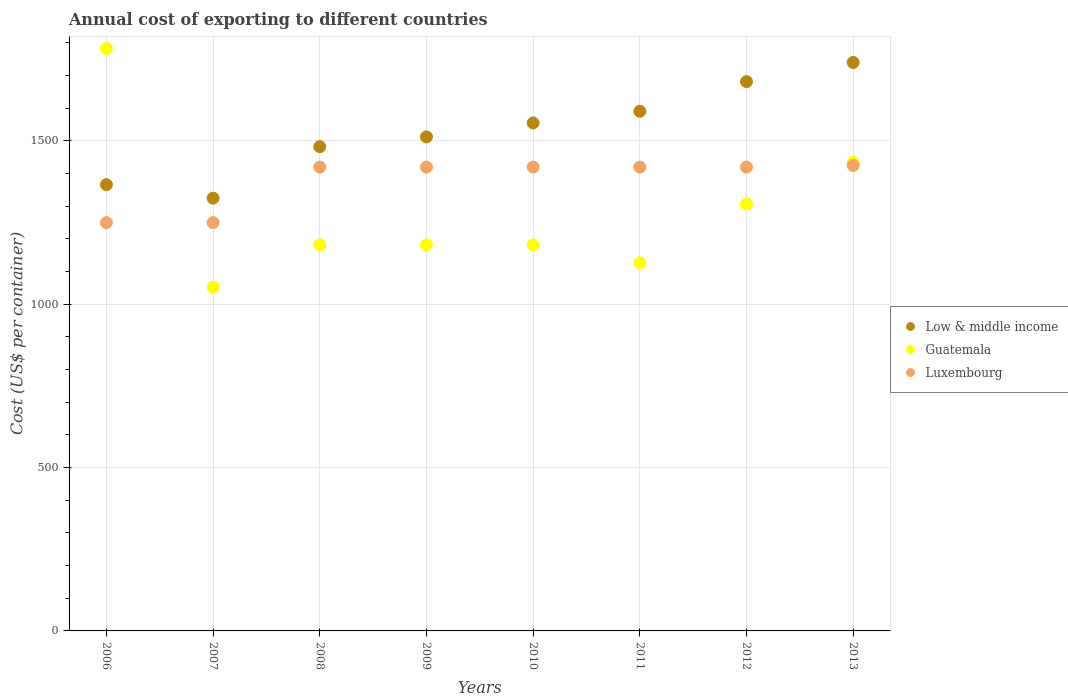How many different coloured dotlines are there?
Give a very brief answer. 3. Is the number of dotlines equal to the number of legend labels?
Offer a very short reply. Yes. What is the total annual cost of exporting in Luxembourg in 2007?
Provide a succinct answer. 1250. Across all years, what is the maximum total annual cost of exporting in Low & middle income?
Make the answer very short. 1740.31. Across all years, what is the minimum total annual cost of exporting in Guatemala?
Your answer should be very brief. 1052. In which year was the total annual cost of exporting in Luxembourg maximum?
Keep it short and to the point. 2013. In which year was the total annual cost of exporting in Luxembourg minimum?
Give a very brief answer. 2006. What is the total total annual cost of exporting in Guatemala in the graph?
Your response must be concise. 1.02e+04. What is the difference between the total annual cost of exporting in Low & middle income in 2011 and that in 2013?
Offer a very short reply. -149.51. What is the difference between the total annual cost of exporting in Guatemala in 2007 and the total annual cost of exporting in Luxembourg in 2010?
Give a very brief answer. -368. What is the average total annual cost of exporting in Luxembourg per year?
Ensure brevity in your answer.  1378.12. In the year 2012, what is the difference between the total annual cost of exporting in Low & middle income and total annual cost of exporting in Guatemala?
Your answer should be very brief. 374.57. In how many years, is the total annual cost of exporting in Guatemala greater than 500 US$?
Provide a succinct answer. 8. What is the ratio of the total annual cost of exporting in Luxembourg in 2008 to that in 2012?
Provide a short and direct response. 1. Is the difference between the total annual cost of exporting in Low & middle income in 2009 and 2010 greater than the difference between the total annual cost of exporting in Guatemala in 2009 and 2010?
Provide a succinct answer. No. What is the difference between the highest and the lowest total annual cost of exporting in Luxembourg?
Provide a succinct answer. 175. In how many years, is the total annual cost of exporting in Low & middle income greater than the average total annual cost of exporting in Low & middle income taken over all years?
Make the answer very short. 4. Is the total annual cost of exporting in Low & middle income strictly less than the total annual cost of exporting in Guatemala over the years?
Your answer should be compact. No. How many years are there in the graph?
Your answer should be very brief. 8. What is the difference between two consecutive major ticks on the Y-axis?
Make the answer very short. 500. Are the values on the major ticks of Y-axis written in scientific E-notation?
Your response must be concise. No. Does the graph contain grids?
Offer a very short reply. Yes. Where does the legend appear in the graph?
Offer a terse response. Center right. How are the legend labels stacked?
Your answer should be compact. Vertical. What is the title of the graph?
Make the answer very short. Annual cost of exporting to different countries. What is the label or title of the Y-axis?
Your answer should be very brief. Cost (US$ per container). What is the Cost (US$ per container) of Low & middle income in 2006?
Ensure brevity in your answer.  1366.18. What is the Cost (US$ per container) in Guatemala in 2006?
Your response must be concise. 1783. What is the Cost (US$ per container) of Luxembourg in 2006?
Offer a very short reply. 1250. What is the Cost (US$ per container) of Low & middle income in 2007?
Provide a succinct answer. 1324.86. What is the Cost (US$ per container) of Guatemala in 2007?
Offer a very short reply. 1052. What is the Cost (US$ per container) in Luxembourg in 2007?
Your answer should be very brief. 1250. What is the Cost (US$ per container) of Low & middle income in 2008?
Offer a very short reply. 1482.53. What is the Cost (US$ per container) of Guatemala in 2008?
Ensure brevity in your answer.  1182. What is the Cost (US$ per container) in Luxembourg in 2008?
Give a very brief answer. 1420. What is the Cost (US$ per container) in Low & middle income in 2009?
Offer a terse response. 1512.47. What is the Cost (US$ per container) of Guatemala in 2009?
Keep it short and to the point. 1182. What is the Cost (US$ per container) in Luxembourg in 2009?
Ensure brevity in your answer.  1420. What is the Cost (US$ per container) of Low & middle income in 2010?
Give a very brief answer. 1555.13. What is the Cost (US$ per container) of Guatemala in 2010?
Make the answer very short. 1182. What is the Cost (US$ per container) of Luxembourg in 2010?
Ensure brevity in your answer.  1420. What is the Cost (US$ per container) in Low & middle income in 2011?
Your response must be concise. 1590.8. What is the Cost (US$ per container) in Guatemala in 2011?
Offer a very short reply. 1127. What is the Cost (US$ per container) in Luxembourg in 2011?
Your answer should be compact. 1420. What is the Cost (US$ per container) of Low & middle income in 2012?
Offer a terse response. 1681.57. What is the Cost (US$ per container) in Guatemala in 2012?
Offer a terse response. 1307. What is the Cost (US$ per container) in Luxembourg in 2012?
Offer a terse response. 1420. What is the Cost (US$ per container) of Low & middle income in 2013?
Offer a terse response. 1740.31. What is the Cost (US$ per container) of Guatemala in 2013?
Ensure brevity in your answer.  1435. What is the Cost (US$ per container) of Luxembourg in 2013?
Give a very brief answer. 1425. Across all years, what is the maximum Cost (US$ per container) in Low & middle income?
Ensure brevity in your answer.  1740.31. Across all years, what is the maximum Cost (US$ per container) of Guatemala?
Your answer should be compact. 1783. Across all years, what is the maximum Cost (US$ per container) in Luxembourg?
Ensure brevity in your answer.  1425. Across all years, what is the minimum Cost (US$ per container) in Low & middle income?
Make the answer very short. 1324.86. Across all years, what is the minimum Cost (US$ per container) in Guatemala?
Offer a very short reply. 1052. Across all years, what is the minimum Cost (US$ per container) of Luxembourg?
Keep it short and to the point. 1250. What is the total Cost (US$ per container) in Low & middle income in the graph?
Your response must be concise. 1.23e+04. What is the total Cost (US$ per container) in Guatemala in the graph?
Keep it short and to the point. 1.02e+04. What is the total Cost (US$ per container) in Luxembourg in the graph?
Make the answer very short. 1.10e+04. What is the difference between the Cost (US$ per container) of Low & middle income in 2006 and that in 2007?
Ensure brevity in your answer.  41.32. What is the difference between the Cost (US$ per container) of Guatemala in 2006 and that in 2007?
Make the answer very short. 731. What is the difference between the Cost (US$ per container) of Luxembourg in 2006 and that in 2007?
Ensure brevity in your answer.  0. What is the difference between the Cost (US$ per container) in Low & middle income in 2006 and that in 2008?
Your response must be concise. -116.35. What is the difference between the Cost (US$ per container) of Guatemala in 2006 and that in 2008?
Offer a terse response. 601. What is the difference between the Cost (US$ per container) in Luxembourg in 2006 and that in 2008?
Keep it short and to the point. -170. What is the difference between the Cost (US$ per container) in Low & middle income in 2006 and that in 2009?
Ensure brevity in your answer.  -146.29. What is the difference between the Cost (US$ per container) in Guatemala in 2006 and that in 2009?
Your answer should be compact. 601. What is the difference between the Cost (US$ per container) of Luxembourg in 2006 and that in 2009?
Make the answer very short. -170. What is the difference between the Cost (US$ per container) in Low & middle income in 2006 and that in 2010?
Make the answer very short. -188.96. What is the difference between the Cost (US$ per container) of Guatemala in 2006 and that in 2010?
Your answer should be compact. 601. What is the difference between the Cost (US$ per container) in Luxembourg in 2006 and that in 2010?
Offer a terse response. -170. What is the difference between the Cost (US$ per container) in Low & middle income in 2006 and that in 2011?
Make the answer very short. -224.63. What is the difference between the Cost (US$ per container) of Guatemala in 2006 and that in 2011?
Your response must be concise. 656. What is the difference between the Cost (US$ per container) of Luxembourg in 2006 and that in 2011?
Offer a terse response. -170. What is the difference between the Cost (US$ per container) in Low & middle income in 2006 and that in 2012?
Offer a terse response. -315.39. What is the difference between the Cost (US$ per container) in Guatemala in 2006 and that in 2012?
Your response must be concise. 476. What is the difference between the Cost (US$ per container) in Luxembourg in 2006 and that in 2012?
Your answer should be compact. -170. What is the difference between the Cost (US$ per container) of Low & middle income in 2006 and that in 2013?
Make the answer very short. -374.13. What is the difference between the Cost (US$ per container) of Guatemala in 2006 and that in 2013?
Ensure brevity in your answer.  348. What is the difference between the Cost (US$ per container) in Luxembourg in 2006 and that in 2013?
Provide a succinct answer. -175. What is the difference between the Cost (US$ per container) in Low & middle income in 2007 and that in 2008?
Provide a short and direct response. -157.67. What is the difference between the Cost (US$ per container) in Guatemala in 2007 and that in 2008?
Give a very brief answer. -130. What is the difference between the Cost (US$ per container) in Luxembourg in 2007 and that in 2008?
Your response must be concise. -170. What is the difference between the Cost (US$ per container) in Low & middle income in 2007 and that in 2009?
Your answer should be very brief. -187.61. What is the difference between the Cost (US$ per container) in Guatemala in 2007 and that in 2009?
Keep it short and to the point. -130. What is the difference between the Cost (US$ per container) in Luxembourg in 2007 and that in 2009?
Offer a very short reply. -170. What is the difference between the Cost (US$ per container) of Low & middle income in 2007 and that in 2010?
Give a very brief answer. -230.28. What is the difference between the Cost (US$ per container) of Guatemala in 2007 and that in 2010?
Your answer should be very brief. -130. What is the difference between the Cost (US$ per container) of Luxembourg in 2007 and that in 2010?
Make the answer very short. -170. What is the difference between the Cost (US$ per container) of Low & middle income in 2007 and that in 2011?
Make the answer very short. -265.95. What is the difference between the Cost (US$ per container) of Guatemala in 2007 and that in 2011?
Provide a short and direct response. -75. What is the difference between the Cost (US$ per container) in Luxembourg in 2007 and that in 2011?
Make the answer very short. -170. What is the difference between the Cost (US$ per container) in Low & middle income in 2007 and that in 2012?
Give a very brief answer. -356.71. What is the difference between the Cost (US$ per container) of Guatemala in 2007 and that in 2012?
Offer a very short reply. -255. What is the difference between the Cost (US$ per container) of Luxembourg in 2007 and that in 2012?
Make the answer very short. -170. What is the difference between the Cost (US$ per container) of Low & middle income in 2007 and that in 2013?
Ensure brevity in your answer.  -415.45. What is the difference between the Cost (US$ per container) of Guatemala in 2007 and that in 2013?
Your answer should be very brief. -383. What is the difference between the Cost (US$ per container) in Luxembourg in 2007 and that in 2013?
Offer a very short reply. -175. What is the difference between the Cost (US$ per container) of Low & middle income in 2008 and that in 2009?
Your answer should be very brief. -29.94. What is the difference between the Cost (US$ per container) of Guatemala in 2008 and that in 2009?
Your response must be concise. 0. What is the difference between the Cost (US$ per container) of Low & middle income in 2008 and that in 2010?
Give a very brief answer. -72.61. What is the difference between the Cost (US$ per container) in Guatemala in 2008 and that in 2010?
Your response must be concise. 0. What is the difference between the Cost (US$ per container) of Luxembourg in 2008 and that in 2010?
Provide a succinct answer. 0. What is the difference between the Cost (US$ per container) in Low & middle income in 2008 and that in 2011?
Offer a terse response. -108.27. What is the difference between the Cost (US$ per container) in Low & middle income in 2008 and that in 2012?
Give a very brief answer. -199.04. What is the difference between the Cost (US$ per container) in Guatemala in 2008 and that in 2012?
Your answer should be very brief. -125. What is the difference between the Cost (US$ per container) in Low & middle income in 2008 and that in 2013?
Provide a short and direct response. -257.78. What is the difference between the Cost (US$ per container) of Guatemala in 2008 and that in 2013?
Provide a short and direct response. -253. What is the difference between the Cost (US$ per container) of Low & middle income in 2009 and that in 2010?
Your answer should be compact. -42.67. What is the difference between the Cost (US$ per container) in Guatemala in 2009 and that in 2010?
Your response must be concise. 0. What is the difference between the Cost (US$ per container) of Low & middle income in 2009 and that in 2011?
Your response must be concise. -78.33. What is the difference between the Cost (US$ per container) of Guatemala in 2009 and that in 2011?
Your response must be concise. 55. What is the difference between the Cost (US$ per container) in Luxembourg in 2009 and that in 2011?
Offer a terse response. 0. What is the difference between the Cost (US$ per container) of Low & middle income in 2009 and that in 2012?
Your answer should be very brief. -169.1. What is the difference between the Cost (US$ per container) of Guatemala in 2009 and that in 2012?
Ensure brevity in your answer.  -125. What is the difference between the Cost (US$ per container) in Luxembourg in 2009 and that in 2012?
Your response must be concise. 0. What is the difference between the Cost (US$ per container) in Low & middle income in 2009 and that in 2013?
Offer a very short reply. -227.84. What is the difference between the Cost (US$ per container) in Guatemala in 2009 and that in 2013?
Ensure brevity in your answer.  -253. What is the difference between the Cost (US$ per container) of Low & middle income in 2010 and that in 2011?
Give a very brief answer. -35.67. What is the difference between the Cost (US$ per container) in Guatemala in 2010 and that in 2011?
Make the answer very short. 55. What is the difference between the Cost (US$ per container) of Low & middle income in 2010 and that in 2012?
Provide a short and direct response. -126.43. What is the difference between the Cost (US$ per container) in Guatemala in 2010 and that in 2012?
Your answer should be compact. -125. What is the difference between the Cost (US$ per container) of Luxembourg in 2010 and that in 2012?
Your answer should be very brief. 0. What is the difference between the Cost (US$ per container) in Low & middle income in 2010 and that in 2013?
Provide a short and direct response. -185.17. What is the difference between the Cost (US$ per container) of Guatemala in 2010 and that in 2013?
Provide a short and direct response. -253. What is the difference between the Cost (US$ per container) in Luxembourg in 2010 and that in 2013?
Your answer should be compact. -5. What is the difference between the Cost (US$ per container) in Low & middle income in 2011 and that in 2012?
Provide a short and direct response. -90.76. What is the difference between the Cost (US$ per container) in Guatemala in 2011 and that in 2012?
Provide a succinct answer. -180. What is the difference between the Cost (US$ per container) in Luxembourg in 2011 and that in 2012?
Give a very brief answer. 0. What is the difference between the Cost (US$ per container) of Low & middle income in 2011 and that in 2013?
Your response must be concise. -149.51. What is the difference between the Cost (US$ per container) in Guatemala in 2011 and that in 2013?
Keep it short and to the point. -308. What is the difference between the Cost (US$ per container) of Luxembourg in 2011 and that in 2013?
Your answer should be very brief. -5. What is the difference between the Cost (US$ per container) of Low & middle income in 2012 and that in 2013?
Ensure brevity in your answer.  -58.74. What is the difference between the Cost (US$ per container) in Guatemala in 2012 and that in 2013?
Provide a succinct answer. -128. What is the difference between the Cost (US$ per container) in Luxembourg in 2012 and that in 2013?
Offer a terse response. -5. What is the difference between the Cost (US$ per container) in Low & middle income in 2006 and the Cost (US$ per container) in Guatemala in 2007?
Keep it short and to the point. 314.18. What is the difference between the Cost (US$ per container) of Low & middle income in 2006 and the Cost (US$ per container) of Luxembourg in 2007?
Ensure brevity in your answer.  116.18. What is the difference between the Cost (US$ per container) in Guatemala in 2006 and the Cost (US$ per container) in Luxembourg in 2007?
Provide a succinct answer. 533. What is the difference between the Cost (US$ per container) of Low & middle income in 2006 and the Cost (US$ per container) of Guatemala in 2008?
Ensure brevity in your answer.  184.18. What is the difference between the Cost (US$ per container) of Low & middle income in 2006 and the Cost (US$ per container) of Luxembourg in 2008?
Your answer should be compact. -53.82. What is the difference between the Cost (US$ per container) in Guatemala in 2006 and the Cost (US$ per container) in Luxembourg in 2008?
Give a very brief answer. 363. What is the difference between the Cost (US$ per container) of Low & middle income in 2006 and the Cost (US$ per container) of Guatemala in 2009?
Your answer should be compact. 184.18. What is the difference between the Cost (US$ per container) of Low & middle income in 2006 and the Cost (US$ per container) of Luxembourg in 2009?
Ensure brevity in your answer.  -53.82. What is the difference between the Cost (US$ per container) of Guatemala in 2006 and the Cost (US$ per container) of Luxembourg in 2009?
Your response must be concise. 363. What is the difference between the Cost (US$ per container) of Low & middle income in 2006 and the Cost (US$ per container) of Guatemala in 2010?
Keep it short and to the point. 184.18. What is the difference between the Cost (US$ per container) of Low & middle income in 2006 and the Cost (US$ per container) of Luxembourg in 2010?
Ensure brevity in your answer.  -53.82. What is the difference between the Cost (US$ per container) of Guatemala in 2006 and the Cost (US$ per container) of Luxembourg in 2010?
Offer a terse response. 363. What is the difference between the Cost (US$ per container) of Low & middle income in 2006 and the Cost (US$ per container) of Guatemala in 2011?
Your answer should be very brief. 239.18. What is the difference between the Cost (US$ per container) in Low & middle income in 2006 and the Cost (US$ per container) in Luxembourg in 2011?
Provide a short and direct response. -53.82. What is the difference between the Cost (US$ per container) of Guatemala in 2006 and the Cost (US$ per container) of Luxembourg in 2011?
Ensure brevity in your answer.  363. What is the difference between the Cost (US$ per container) of Low & middle income in 2006 and the Cost (US$ per container) of Guatemala in 2012?
Provide a short and direct response. 59.18. What is the difference between the Cost (US$ per container) of Low & middle income in 2006 and the Cost (US$ per container) of Luxembourg in 2012?
Give a very brief answer. -53.82. What is the difference between the Cost (US$ per container) in Guatemala in 2006 and the Cost (US$ per container) in Luxembourg in 2012?
Your answer should be compact. 363. What is the difference between the Cost (US$ per container) in Low & middle income in 2006 and the Cost (US$ per container) in Guatemala in 2013?
Provide a succinct answer. -68.82. What is the difference between the Cost (US$ per container) in Low & middle income in 2006 and the Cost (US$ per container) in Luxembourg in 2013?
Give a very brief answer. -58.82. What is the difference between the Cost (US$ per container) in Guatemala in 2006 and the Cost (US$ per container) in Luxembourg in 2013?
Offer a terse response. 358. What is the difference between the Cost (US$ per container) of Low & middle income in 2007 and the Cost (US$ per container) of Guatemala in 2008?
Provide a succinct answer. 142.86. What is the difference between the Cost (US$ per container) in Low & middle income in 2007 and the Cost (US$ per container) in Luxembourg in 2008?
Make the answer very short. -95.14. What is the difference between the Cost (US$ per container) in Guatemala in 2007 and the Cost (US$ per container) in Luxembourg in 2008?
Keep it short and to the point. -368. What is the difference between the Cost (US$ per container) of Low & middle income in 2007 and the Cost (US$ per container) of Guatemala in 2009?
Give a very brief answer. 142.86. What is the difference between the Cost (US$ per container) in Low & middle income in 2007 and the Cost (US$ per container) in Luxembourg in 2009?
Offer a very short reply. -95.14. What is the difference between the Cost (US$ per container) in Guatemala in 2007 and the Cost (US$ per container) in Luxembourg in 2009?
Ensure brevity in your answer.  -368. What is the difference between the Cost (US$ per container) in Low & middle income in 2007 and the Cost (US$ per container) in Guatemala in 2010?
Your answer should be compact. 142.86. What is the difference between the Cost (US$ per container) of Low & middle income in 2007 and the Cost (US$ per container) of Luxembourg in 2010?
Offer a very short reply. -95.14. What is the difference between the Cost (US$ per container) in Guatemala in 2007 and the Cost (US$ per container) in Luxembourg in 2010?
Provide a short and direct response. -368. What is the difference between the Cost (US$ per container) of Low & middle income in 2007 and the Cost (US$ per container) of Guatemala in 2011?
Your answer should be very brief. 197.86. What is the difference between the Cost (US$ per container) in Low & middle income in 2007 and the Cost (US$ per container) in Luxembourg in 2011?
Offer a very short reply. -95.14. What is the difference between the Cost (US$ per container) of Guatemala in 2007 and the Cost (US$ per container) of Luxembourg in 2011?
Keep it short and to the point. -368. What is the difference between the Cost (US$ per container) in Low & middle income in 2007 and the Cost (US$ per container) in Guatemala in 2012?
Offer a terse response. 17.86. What is the difference between the Cost (US$ per container) of Low & middle income in 2007 and the Cost (US$ per container) of Luxembourg in 2012?
Offer a terse response. -95.14. What is the difference between the Cost (US$ per container) in Guatemala in 2007 and the Cost (US$ per container) in Luxembourg in 2012?
Offer a terse response. -368. What is the difference between the Cost (US$ per container) in Low & middle income in 2007 and the Cost (US$ per container) in Guatemala in 2013?
Your answer should be compact. -110.14. What is the difference between the Cost (US$ per container) of Low & middle income in 2007 and the Cost (US$ per container) of Luxembourg in 2013?
Keep it short and to the point. -100.14. What is the difference between the Cost (US$ per container) of Guatemala in 2007 and the Cost (US$ per container) of Luxembourg in 2013?
Make the answer very short. -373. What is the difference between the Cost (US$ per container) in Low & middle income in 2008 and the Cost (US$ per container) in Guatemala in 2009?
Give a very brief answer. 300.53. What is the difference between the Cost (US$ per container) in Low & middle income in 2008 and the Cost (US$ per container) in Luxembourg in 2009?
Your answer should be compact. 62.53. What is the difference between the Cost (US$ per container) of Guatemala in 2008 and the Cost (US$ per container) of Luxembourg in 2009?
Offer a very short reply. -238. What is the difference between the Cost (US$ per container) of Low & middle income in 2008 and the Cost (US$ per container) of Guatemala in 2010?
Keep it short and to the point. 300.53. What is the difference between the Cost (US$ per container) of Low & middle income in 2008 and the Cost (US$ per container) of Luxembourg in 2010?
Ensure brevity in your answer.  62.53. What is the difference between the Cost (US$ per container) in Guatemala in 2008 and the Cost (US$ per container) in Luxembourg in 2010?
Ensure brevity in your answer.  -238. What is the difference between the Cost (US$ per container) of Low & middle income in 2008 and the Cost (US$ per container) of Guatemala in 2011?
Give a very brief answer. 355.53. What is the difference between the Cost (US$ per container) in Low & middle income in 2008 and the Cost (US$ per container) in Luxembourg in 2011?
Your answer should be very brief. 62.53. What is the difference between the Cost (US$ per container) in Guatemala in 2008 and the Cost (US$ per container) in Luxembourg in 2011?
Ensure brevity in your answer.  -238. What is the difference between the Cost (US$ per container) of Low & middle income in 2008 and the Cost (US$ per container) of Guatemala in 2012?
Give a very brief answer. 175.53. What is the difference between the Cost (US$ per container) in Low & middle income in 2008 and the Cost (US$ per container) in Luxembourg in 2012?
Your answer should be compact. 62.53. What is the difference between the Cost (US$ per container) of Guatemala in 2008 and the Cost (US$ per container) of Luxembourg in 2012?
Make the answer very short. -238. What is the difference between the Cost (US$ per container) of Low & middle income in 2008 and the Cost (US$ per container) of Guatemala in 2013?
Your answer should be very brief. 47.53. What is the difference between the Cost (US$ per container) of Low & middle income in 2008 and the Cost (US$ per container) of Luxembourg in 2013?
Offer a very short reply. 57.53. What is the difference between the Cost (US$ per container) of Guatemala in 2008 and the Cost (US$ per container) of Luxembourg in 2013?
Keep it short and to the point. -243. What is the difference between the Cost (US$ per container) in Low & middle income in 2009 and the Cost (US$ per container) in Guatemala in 2010?
Keep it short and to the point. 330.47. What is the difference between the Cost (US$ per container) of Low & middle income in 2009 and the Cost (US$ per container) of Luxembourg in 2010?
Your answer should be very brief. 92.47. What is the difference between the Cost (US$ per container) of Guatemala in 2009 and the Cost (US$ per container) of Luxembourg in 2010?
Give a very brief answer. -238. What is the difference between the Cost (US$ per container) of Low & middle income in 2009 and the Cost (US$ per container) of Guatemala in 2011?
Provide a short and direct response. 385.47. What is the difference between the Cost (US$ per container) of Low & middle income in 2009 and the Cost (US$ per container) of Luxembourg in 2011?
Ensure brevity in your answer.  92.47. What is the difference between the Cost (US$ per container) in Guatemala in 2009 and the Cost (US$ per container) in Luxembourg in 2011?
Your response must be concise. -238. What is the difference between the Cost (US$ per container) of Low & middle income in 2009 and the Cost (US$ per container) of Guatemala in 2012?
Provide a short and direct response. 205.47. What is the difference between the Cost (US$ per container) of Low & middle income in 2009 and the Cost (US$ per container) of Luxembourg in 2012?
Ensure brevity in your answer.  92.47. What is the difference between the Cost (US$ per container) in Guatemala in 2009 and the Cost (US$ per container) in Luxembourg in 2012?
Offer a terse response. -238. What is the difference between the Cost (US$ per container) in Low & middle income in 2009 and the Cost (US$ per container) in Guatemala in 2013?
Your response must be concise. 77.47. What is the difference between the Cost (US$ per container) of Low & middle income in 2009 and the Cost (US$ per container) of Luxembourg in 2013?
Your answer should be very brief. 87.47. What is the difference between the Cost (US$ per container) in Guatemala in 2009 and the Cost (US$ per container) in Luxembourg in 2013?
Offer a very short reply. -243. What is the difference between the Cost (US$ per container) of Low & middle income in 2010 and the Cost (US$ per container) of Guatemala in 2011?
Your answer should be very brief. 428.13. What is the difference between the Cost (US$ per container) of Low & middle income in 2010 and the Cost (US$ per container) of Luxembourg in 2011?
Provide a succinct answer. 135.13. What is the difference between the Cost (US$ per container) in Guatemala in 2010 and the Cost (US$ per container) in Luxembourg in 2011?
Make the answer very short. -238. What is the difference between the Cost (US$ per container) of Low & middle income in 2010 and the Cost (US$ per container) of Guatemala in 2012?
Ensure brevity in your answer.  248.13. What is the difference between the Cost (US$ per container) of Low & middle income in 2010 and the Cost (US$ per container) of Luxembourg in 2012?
Make the answer very short. 135.13. What is the difference between the Cost (US$ per container) of Guatemala in 2010 and the Cost (US$ per container) of Luxembourg in 2012?
Give a very brief answer. -238. What is the difference between the Cost (US$ per container) of Low & middle income in 2010 and the Cost (US$ per container) of Guatemala in 2013?
Your answer should be compact. 120.13. What is the difference between the Cost (US$ per container) in Low & middle income in 2010 and the Cost (US$ per container) in Luxembourg in 2013?
Ensure brevity in your answer.  130.13. What is the difference between the Cost (US$ per container) in Guatemala in 2010 and the Cost (US$ per container) in Luxembourg in 2013?
Make the answer very short. -243. What is the difference between the Cost (US$ per container) in Low & middle income in 2011 and the Cost (US$ per container) in Guatemala in 2012?
Keep it short and to the point. 283.8. What is the difference between the Cost (US$ per container) of Low & middle income in 2011 and the Cost (US$ per container) of Luxembourg in 2012?
Your response must be concise. 170.8. What is the difference between the Cost (US$ per container) of Guatemala in 2011 and the Cost (US$ per container) of Luxembourg in 2012?
Your response must be concise. -293. What is the difference between the Cost (US$ per container) in Low & middle income in 2011 and the Cost (US$ per container) in Guatemala in 2013?
Make the answer very short. 155.8. What is the difference between the Cost (US$ per container) of Low & middle income in 2011 and the Cost (US$ per container) of Luxembourg in 2013?
Provide a short and direct response. 165.8. What is the difference between the Cost (US$ per container) of Guatemala in 2011 and the Cost (US$ per container) of Luxembourg in 2013?
Provide a succinct answer. -298. What is the difference between the Cost (US$ per container) of Low & middle income in 2012 and the Cost (US$ per container) of Guatemala in 2013?
Your answer should be compact. 246.57. What is the difference between the Cost (US$ per container) in Low & middle income in 2012 and the Cost (US$ per container) in Luxembourg in 2013?
Provide a succinct answer. 256.57. What is the difference between the Cost (US$ per container) in Guatemala in 2012 and the Cost (US$ per container) in Luxembourg in 2013?
Ensure brevity in your answer.  -118. What is the average Cost (US$ per container) in Low & middle income per year?
Make the answer very short. 1531.73. What is the average Cost (US$ per container) of Guatemala per year?
Keep it short and to the point. 1281.25. What is the average Cost (US$ per container) in Luxembourg per year?
Keep it short and to the point. 1378.12. In the year 2006, what is the difference between the Cost (US$ per container) in Low & middle income and Cost (US$ per container) in Guatemala?
Your answer should be compact. -416.82. In the year 2006, what is the difference between the Cost (US$ per container) in Low & middle income and Cost (US$ per container) in Luxembourg?
Your answer should be very brief. 116.18. In the year 2006, what is the difference between the Cost (US$ per container) in Guatemala and Cost (US$ per container) in Luxembourg?
Offer a terse response. 533. In the year 2007, what is the difference between the Cost (US$ per container) in Low & middle income and Cost (US$ per container) in Guatemala?
Your answer should be compact. 272.86. In the year 2007, what is the difference between the Cost (US$ per container) of Low & middle income and Cost (US$ per container) of Luxembourg?
Provide a succinct answer. 74.86. In the year 2007, what is the difference between the Cost (US$ per container) in Guatemala and Cost (US$ per container) in Luxembourg?
Provide a succinct answer. -198. In the year 2008, what is the difference between the Cost (US$ per container) in Low & middle income and Cost (US$ per container) in Guatemala?
Keep it short and to the point. 300.53. In the year 2008, what is the difference between the Cost (US$ per container) of Low & middle income and Cost (US$ per container) of Luxembourg?
Offer a terse response. 62.53. In the year 2008, what is the difference between the Cost (US$ per container) in Guatemala and Cost (US$ per container) in Luxembourg?
Provide a succinct answer. -238. In the year 2009, what is the difference between the Cost (US$ per container) of Low & middle income and Cost (US$ per container) of Guatemala?
Offer a terse response. 330.47. In the year 2009, what is the difference between the Cost (US$ per container) in Low & middle income and Cost (US$ per container) in Luxembourg?
Offer a very short reply. 92.47. In the year 2009, what is the difference between the Cost (US$ per container) of Guatemala and Cost (US$ per container) of Luxembourg?
Give a very brief answer. -238. In the year 2010, what is the difference between the Cost (US$ per container) of Low & middle income and Cost (US$ per container) of Guatemala?
Your answer should be compact. 373.13. In the year 2010, what is the difference between the Cost (US$ per container) in Low & middle income and Cost (US$ per container) in Luxembourg?
Provide a succinct answer. 135.13. In the year 2010, what is the difference between the Cost (US$ per container) of Guatemala and Cost (US$ per container) of Luxembourg?
Your answer should be compact. -238. In the year 2011, what is the difference between the Cost (US$ per container) of Low & middle income and Cost (US$ per container) of Guatemala?
Make the answer very short. 463.8. In the year 2011, what is the difference between the Cost (US$ per container) in Low & middle income and Cost (US$ per container) in Luxembourg?
Your answer should be very brief. 170.8. In the year 2011, what is the difference between the Cost (US$ per container) of Guatemala and Cost (US$ per container) of Luxembourg?
Keep it short and to the point. -293. In the year 2012, what is the difference between the Cost (US$ per container) in Low & middle income and Cost (US$ per container) in Guatemala?
Offer a terse response. 374.57. In the year 2012, what is the difference between the Cost (US$ per container) of Low & middle income and Cost (US$ per container) of Luxembourg?
Provide a succinct answer. 261.57. In the year 2012, what is the difference between the Cost (US$ per container) in Guatemala and Cost (US$ per container) in Luxembourg?
Provide a short and direct response. -113. In the year 2013, what is the difference between the Cost (US$ per container) of Low & middle income and Cost (US$ per container) of Guatemala?
Make the answer very short. 305.31. In the year 2013, what is the difference between the Cost (US$ per container) of Low & middle income and Cost (US$ per container) of Luxembourg?
Keep it short and to the point. 315.31. In the year 2013, what is the difference between the Cost (US$ per container) in Guatemala and Cost (US$ per container) in Luxembourg?
Offer a terse response. 10. What is the ratio of the Cost (US$ per container) of Low & middle income in 2006 to that in 2007?
Make the answer very short. 1.03. What is the ratio of the Cost (US$ per container) of Guatemala in 2006 to that in 2007?
Offer a very short reply. 1.69. What is the ratio of the Cost (US$ per container) of Luxembourg in 2006 to that in 2007?
Your response must be concise. 1. What is the ratio of the Cost (US$ per container) in Low & middle income in 2006 to that in 2008?
Provide a short and direct response. 0.92. What is the ratio of the Cost (US$ per container) of Guatemala in 2006 to that in 2008?
Give a very brief answer. 1.51. What is the ratio of the Cost (US$ per container) of Luxembourg in 2006 to that in 2008?
Provide a succinct answer. 0.88. What is the ratio of the Cost (US$ per container) of Low & middle income in 2006 to that in 2009?
Make the answer very short. 0.9. What is the ratio of the Cost (US$ per container) in Guatemala in 2006 to that in 2009?
Your response must be concise. 1.51. What is the ratio of the Cost (US$ per container) of Luxembourg in 2006 to that in 2009?
Make the answer very short. 0.88. What is the ratio of the Cost (US$ per container) in Low & middle income in 2006 to that in 2010?
Offer a terse response. 0.88. What is the ratio of the Cost (US$ per container) of Guatemala in 2006 to that in 2010?
Make the answer very short. 1.51. What is the ratio of the Cost (US$ per container) in Luxembourg in 2006 to that in 2010?
Provide a short and direct response. 0.88. What is the ratio of the Cost (US$ per container) in Low & middle income in 2006 to that in 2011?
Make the answer very short. 0.86. What is the ratio of the Cost (US$ per container) of Guatemala in 2006 to that in 2011?
Ensure brevity in your answer.  1.58. What is the ratio of the Cost (US$ per container) in Luxembourg in 2006 to that in 2011?
Provide a short and direct response. 0.88. What is the ratio of the Cost (US$ per container) in Low & middle income in 2006 to that in 2012?
Give a very brief answer. 0.81. What is the ratio of the Cost (US$ per container) in Guatemala in 2006 to that in 2012?
Your answer should be compact. 1.36. What is the ratio of the Cost (US$ per container) of Luxembourg in 2006 to that in 2012?
Give a very brief answer. 0.88. What is the ratio of the Cost (US$ per container) in Low & middle income in 2006 to that in 2013?
Keep it short and to the point. 0.79. What is the ratio of the Cost (US$ per container) in Guatemala in 2006 to that in 2013?
Your answer should be compact. 1.24. What is the ratio of the Cost (US$ per container) in Luxembourg in 2006 to that in 2013?
Offer a terse response. 0.88. What is the ratio of the Cost (US$ per container) of Low & middle income in 2007 to that in 2008?
Your answer should be very brief. 0.89. What is the ratio of the Cost (US$ per container) in Guatemala in 2007 to that in 2008?
Offer a terse response. 0.89. What is the ratio of the Cost (US$ per container) of Luxembourg in 2007 to that in 2008?
Your response must be concise. 0.88. What is the ratio of the Cost (US$ per container) in Low & middle income in 2007 to that in 2009?
Give a very brief answer. 0.88. What is the ratio of the Cost (US$ per container) of Guatemala in 2007 to that in 2009?
Your response must be concise. 0.89. What is the ratio of the Cost (US$ per container) in Luxembourg in 2007 to that in 2009?
Your response must be concise. 0.88. What is the ratio of the Cost (US$ per container) in Low & middle income in 2007 to that in 2010?
Provide a succinct answer. 0.85. What is the ratio of the Cost (US$ per container) in Guatemala in 2007 to that in 2010?
Your response must be concise. 0.89. What is the ratio of the Cost (US$ per container) in Luxembourg in 2007 to that in 2010?
Your response must be concise. 0.88. What is the ratio of the Cost (US$ per container) of Low & middle income in 2007 to that in 2011?
Keep it short and to the point. 0.83. What is the ratio of the Cost (US$ per container) of Guatemala in 2007 to that in 2011?
Offer a terse response. 0.93. What is the ratio of the Cost (US$ per container) of Luxembourg in 2007 to that in 2011?
Provide a succinct answer. 0.88. What is the ratio of the Cost (US$ per container) in Low & middle income in 2007 to that in 2012?
Your answer should be compact. 0.79. What is the ratio of the Cost (US$ per container) in Guatemala in 2007 to that in 2012?
Your response must be concise. 0.8. What is the ratio of the Cost (US$ per container) of Luxembourg in 2007 to that in 2012?
Give a very brief answer. 0.88. What is the ratio of the Cost (US$ per container) in Low & middle income in 2007 to that in 2013?
Your response must be concise. 0.76. What is the ratio of the Cost (US$ per container) in Guatemala in 2007 to that in 2013?
Offer a very short reply. 0.73. What is the ratio of the Cost (US$ per container) in Luxembourg in 2007 to that in 2013?
Your response must be concise. 0.88. What is the ratio of the Cost (US$ per container) of Low & middle income in 2008 to that in 2009?
Keep it short and to the point. 0.98. What is the ratio of the Cost (US$ per container) in Guatemala in 2008 to that in 2009?
Keep it short and to the point. 1. What is the ratio of the Cost (US$ per container) in Low & middle income in 2008 to that in 2010?
Offer a terse response. 0.95. What is the ratio of the Cost (US$ per container) in Guatemala in 2008 to that in 2010?
Give a very brief answer. 1. What is the ratio of the Cost (US$ per container) of Low & middle income in 2008 to that in 2011?
Give a very brief answer. 0.93. What is the ratio of the Cost (US$ per container) in Guatemala in 2008 to that in 2011?
Your answer should be very brief. 1.05. What is the ratio of the Cost (US$ per container) of Low & middle income in 2008 to that in 2012?
Provide a succinct answer. 0.88. What is the ratio of the Cost (US$ per container) in Guatemala in 2008 to that in 2012?
Your response must be concise. 0.9. What is the ratio of the Cost (US$ per container) of Luxembourg in 2008 to that in 2012?
Provide a succinct answer. 1. What is the ratio of the Cost (US$ per container) of Low & middle income in 2008 to that in 2013?
Offer a terse response. 0.85. What is the ratio of the Cost (US$ per container) in Guatemala in 2008 to that in 2013?
Provide a short and direct response. 0.82. What is the ratio of the Cost (US$ per container) of Luxembourg in 2008 to that in 2013?
Offer a terse response. 1. What is the ratio of the Cost (US$ per container) of Low & middle income in 2009 to that in 2010?
Provide a short and direct response. 0.97. What is the ratio of the Cost (US$ per container) of Low & middle income in 2009 to that in 2011?
Provide a succinct answer. 0.95. What is the ratio of the Cost (US$ per container) in Guatemala in 2009 to that in 2011?
Provide a succinct answer. 1.05. What is the ratio of the Cost (US$ per container) of Low & middle income in 2009 to that in 2012?
Offer a terse response. 0.9. What is the ratio of the Cost (US$ per container) of Guatemala in 2009 to that in 2012?
Give a very brief answer. 0.9. What is the ratio of the Cost (US$ per container) of Low & middle income in 2009 to that in 2013?
Your answer should be compact. 0.87. What is the ratio of the Cost (US$ per container) in Guatemala in 2009 to that in 2013?
Your answer should be very brief. 0.82. What is the ratio of the Cost (US$ per container) in Low & middle income in 2010 to that in 2011?
Provide a short and direct response. 0.98. What is the ratio of the Cost (US$ per container) in Guatemala in 2010 to that in 2011?
Your response must be concise. 1.05. What is the ratio of the Cost (US$ per container) in Low & middle income in 2010 to that in 2012?
Provide a succinct answer. 0.92. What is the ratio of the Cost (US$ per container) of Guatemala in 2010 to that in 2012?
Ensure brevity in your answer.  0.9. What is the ratio of the Cost (US$ per container) in Low & middle income in 2010 to that in 2013?
Make the answer very short. 0.89. What is the ratio of the Cost (US$ per container) of Guatemala in 2010 to that in 2013?
Make the answer very short. 0.82. What is the ratio of the Cost (US$ per container) in Luxembourg in 2010 to that in 2013?
Provide a short and direct response. 1. What is the ratio of the Cost (US$ per container) of Low & middle income in 2011 to that in 2012?
Provide a short and direct response. 0.95. What is the ratio of the Cost (US$ per container) in Guatemala in 2011 to that in 2012?
Make the answer very short. 0.86. What is the ratio of the Cost (US$ per container) of Low & middle income in 2011 to that in 2013?
Ensure brevity in your answer.  0.91. What is the ratio of the Cost (US$ per container) in Guatemala in 2011 to that in 2013?
Offer a terse response. 0.79. What is the ratio of the Cost (US$ per container) in Luxembourg in 2011 to that in 2013?
Your response must be concise. 1. What is the ratio of the Cost (US$ per container) in Low & middle income in 2012 to that in 2013?
Your response must be concise. 0.97. What is the ratio of the Cost (US$ per container) of Guatemala in 2012 to that in 2013?
Offer a terse response. 0.91. What is the ratio of the Cost (US$ per container) in Luxembourg in 2012 to that in 2013?
Offer a very short reply. 1. What is the difference between the highest and the second highest Cost (US$ per container) in Low & middle income?
Your answer should be very brief. 58.74. What is the difference between the highest and the second highest Cost (US$ per container) of Guatemala?
Provide a succinct answer. 348. What is the difference between the highest and the second highest Cost (US$ per container) in Luxembourg?
Provide a succinct answer. 5. What is the difference between the highest and the lowest Cost (US$ per container) of Low & middle income?
Offer a terse response. 415.45. What is the difference between the highest and the lowest Cost (US$ per container) in Guatemala?
Offer a very short reply. 731. What is the difference between the highest and the lowest Cost (US$ per container) in Luxembourg?
Provide a succinct answer. 175. 